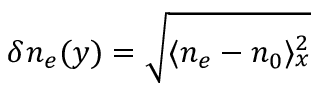Convert formula to latex. <formula><loc_0><loc_0><loc_500><loc_500>\delta n _ { e } ( y ) = \sqrt { \langle n _ { e } - n _ { 0 } \rangle _ { x } ^ { 2 } }</formula> 